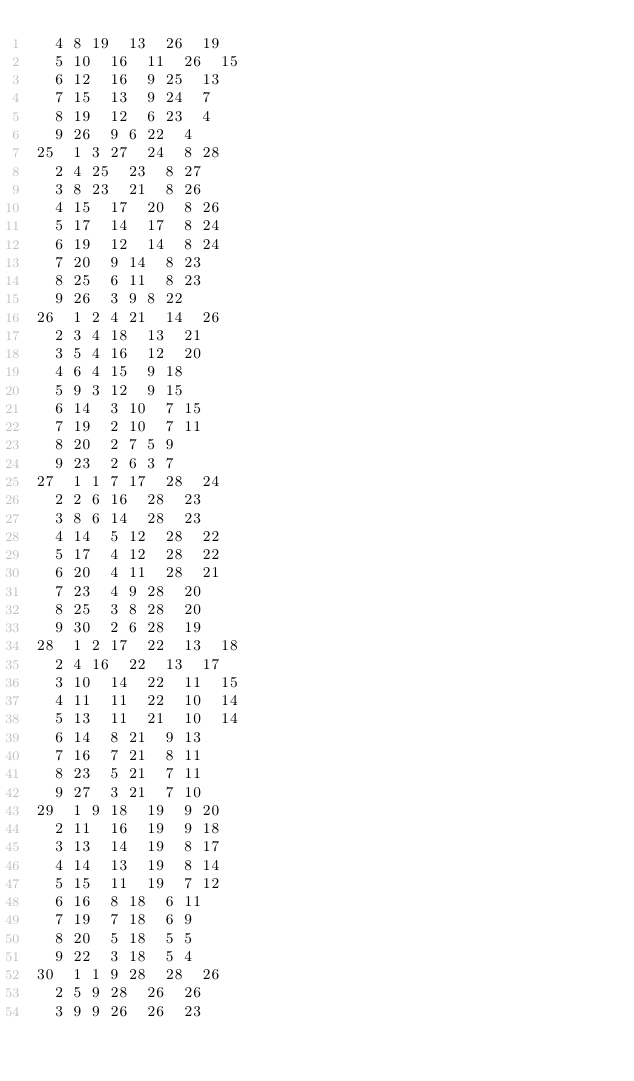<code> <loc_0><loc_0><loc_500><loc_500><_ObjectiveC_>	4	8	19	13	26	19	
	5	10	16	11	26	15	
	6	12	16	9	25	13	
	7	15	13	9	24	7	
	8	19	12	6	23	4	
	9	26	9	6	22	4	
25	1	3	27	24	8	28	
	2	4	25	23	8	27	
	3	8	23	21	8	26	
	4	15	17	20	8	26	
	5	17	14	17	8	24	
	6	19	12	14	8	24	
	7	20	9	14	8	23	
	8	25	6	11	8	23	
	9	26	3	9	8	22	
26	1	2	4	21	14	26	
	2	3	4	18	13	21	
	3	5	4	16	12	20	
	4	6	4	15	9	18	
	5	9	3	12	9	15	
	6	14	3	10	7	15	
	7	19	2	10	7	11	
	8	20	2	7	5	9	
	9	23	2	6	3	7	
27	1	1	7	17	28	24	
	2	2	6	16	28	23	
	3	8	6	14	28	23	
	4	14	5	12	28	22	
	5	17	4	12	28	22	
	6	20	4	11	28	21	
	7	23	4	9	28	20	
	8	25	3	8	28	20	
	9	30	2	6	28	19	
28	1	2	17	22	13	18	
	2	4	16	22	13	17	
	3	10	14	22	11	15	
	4	11	11	22	10	14	
	5	13	11	21	10	14	
	6	14	8	21	9	13	
	7	16	7	21	8	11	
	8	23	5	21	7	11	
	9	27	3	21	7	10	
29	1	9	18	19	9	20	
	2	11	16	19	9	18	
	3	13	14	19	8	17	
	4	14	13	19	8	14	
	5	15	11	19	7	12	
	6	16	8	18	6	11	
	7	19	7	18	6	9	
	8	20	5	18	5	5	
	9	22	3	18	5	4	
30	1	1	9	28	28	26	
	2	5	9	28	26	26	
	3	9	9	26	26	23	</code> 